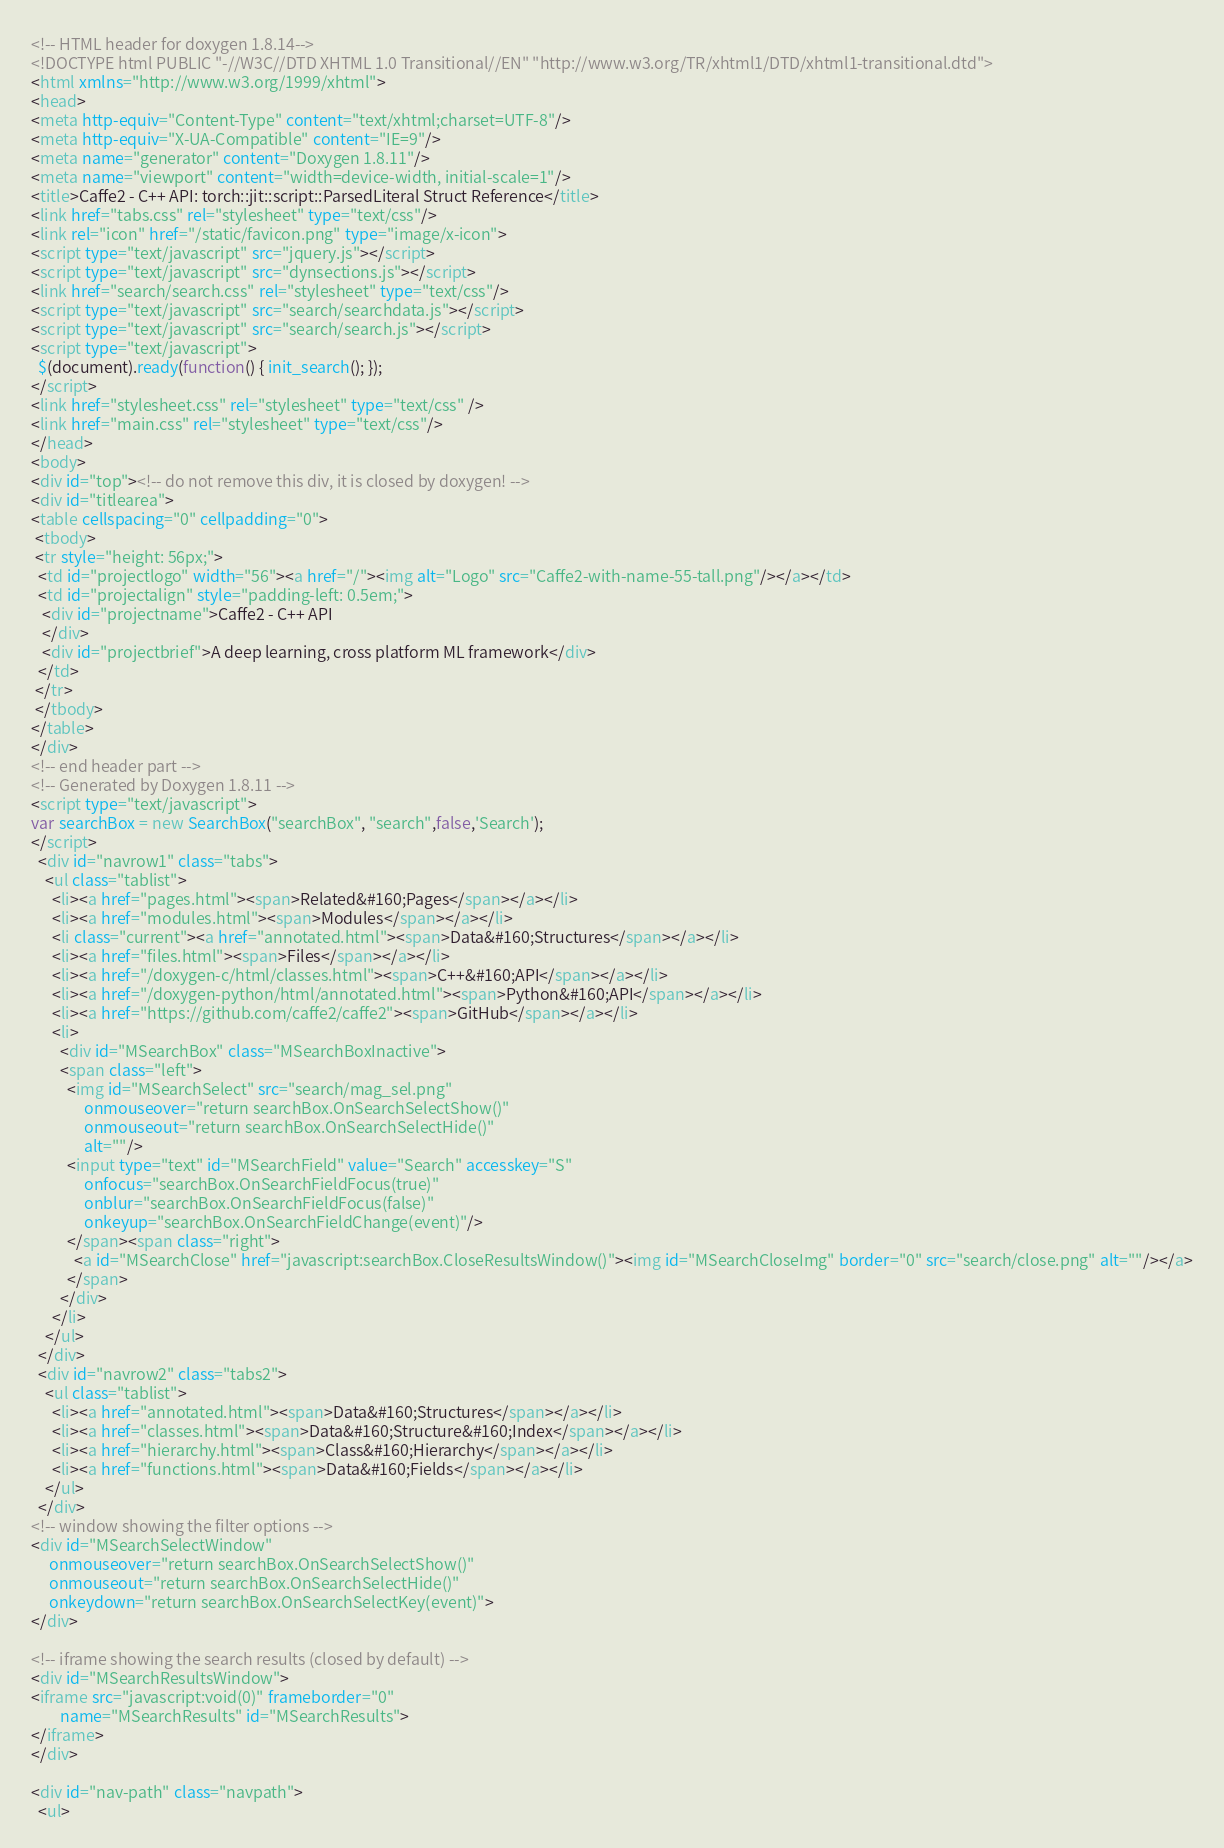<code> <loc_0><loc_0><loc_500><loc_500><_HTML_><!-- HTML header for doxygen 1.8.14-->
<!DOCTYPE html PUBLIC "-//W3C//DTD XHTML 1.0 Transitional//EN" "http://www.w3.org/TR/xhtml1/DTD/xhtml1-transitional.dtd">
<html xmlns="http://www.w3.org/1999/xhtml">
<head>
<meta http-equiv="Content-Type" content="text/xhtml;charset=UTF-8"/>
<meta http-equiv="X-UA-Compatible" content="IE=9"/>
<meta name="generator" content="Doxygen 1.8.11"/>
<meta name="viewport" content="width=device-width, initial-scale=1"/>
<title>Caffe2 - C++ API: torch::jit::script::ParsedLiteral Struct Reference</title>
<link href="tabs.css" rel="stylesheet" type="text/css"/>
<link rel="icon" href="/static/favicon.png" type="image/x-icon">
<script type="text/javascript" src="jquery.js"></script>
<script type="text/javascript" src="dynsections.js"></script>
<link href="search/search.css" rel="stylesheet" type="text/css"/>
<script type="text/javascript" src="search/searchdata.js"></script>
<script type="text/javascript" src="search/search.js"></script>
<script type="text/javascript">
  $(document).ready(function() { init_search(); });
</script>
<link href="stylesheet.css" rel="stylesheet" type="text/css" />
<link href="main.css" rel="stylesheet" type="text/css"/>
</head>
<body>
<div id="top"><!-- do not remove this div, it is closed by doxygen! -->
<div id="titlearea">
<table cellspacing="0" cellpadding="0">
 <tbody>
 <tr style="height: 56px;">
  <td id="projectlogo" width="56"><a href="/"><img alt="Logo" src="Caffe2-with-name-55-tall.png"/></a></td>
  <td id="projectalign" style="padding-left: 0.5em;">
   <div id="projectname">Caffe2 - C++ API
   </div>
   <div id="projectbrief">A deep learning, cross platform ML framework</div>
  </td>
 </tr>
 </tbody>
</table>
</div>
<!-- end header part -->
<!-- Generated by Doxygen 1.8.11 -->
<script type="text/javascript">
var searchBox = new SearchBox("searchBox", "search",false,'Search');
</script>
  <div id="navrow1" class="tabs">
    <ul class="tablist">
      <li><a href="pages.html"><span>Related&#160;Pages</span></a></li>
      <li><a href="modules.html"><span>Modules</span></a></li>
      <li class="current"><a href="annotated.html"><span>Data&#160;Structures</span></a></li>
      <li><a href="files.html"><span>Files</span></a></li>
      <li><a href="/doxygen-c/html/classes.html"><span>C++&#160;API</span></a></li>
      <li><a href="/doxygen-python/html/annotated.html"><span>Python&#160;API</span></a></li>
      <li><a href="https://github.com/caffe2/caffe2"><span>GitHub</span></a></li>
      <li>
        <div id="MSearchBox" class="MSearchBoxInactive">
        <span class="left">
          <img id="MSearchSelect" src="search/mag_sel.png"
               onmouseover="return searchBox.OnSearchSelectShow()"
               onmouseout="return searchBox.OnSearchSelectHide()"
               alt=""/>
          <input type="text" id="MSearchField" value="Search" accesskey="S"
               onfocus="searchBox.OnSearchFieldFocus(true)" 
               onblur="searchBox.OnSearchFieldFocus(false)" 
               onkeyup="searchBox.OnSearchFieldChange(event)"/>
          </span><span class="right">
            <a id="MSearchClose" href="javascript:searchBox.CloseResultsWindow()"><img id="MSearchCloseImg" border="0" src="search/close.png" alt=""/></a>
          </span>
        </div>
      </li>
    </ul>
  </div>
  <div id="navrow2" class="tabs2">
    <ul class="tablist">
      <li><a href="annotated.html"><span>Data&#160;Structures</span></a></li>
      <li><a href="classes.html"><span>Data&#160;Structure&#160;Index</span></a></li>
      <li><a href="hierarchy.html"><span>Class&#160;Hierarchy</span></a></li>
      <li><a href="functions.html"><span>Data&#160;Fields</span></a></li>
    </ul>
  </div>
<!-- window showing the filter options -->
<div id="MSearchSelectWindow"
     onmouseover="return searchBox.OnSearchSelectShow()"
     onmouseout="return searchBox.OnSearchSelectHide()"
     onkeydown="return searchBox.OnSearchSelectKey(event)">
</div>

<!-- iframe showing the search results (closed by default) -->
<div id="MSearchResultsWindow">
<iframe src="javascript:void(0)" frameborder="0" 
        name="MSearchResults" id="MSearchResults">
</iframe>
</div>

<div id="nav-path" class="navpath">
  <ul></code> 